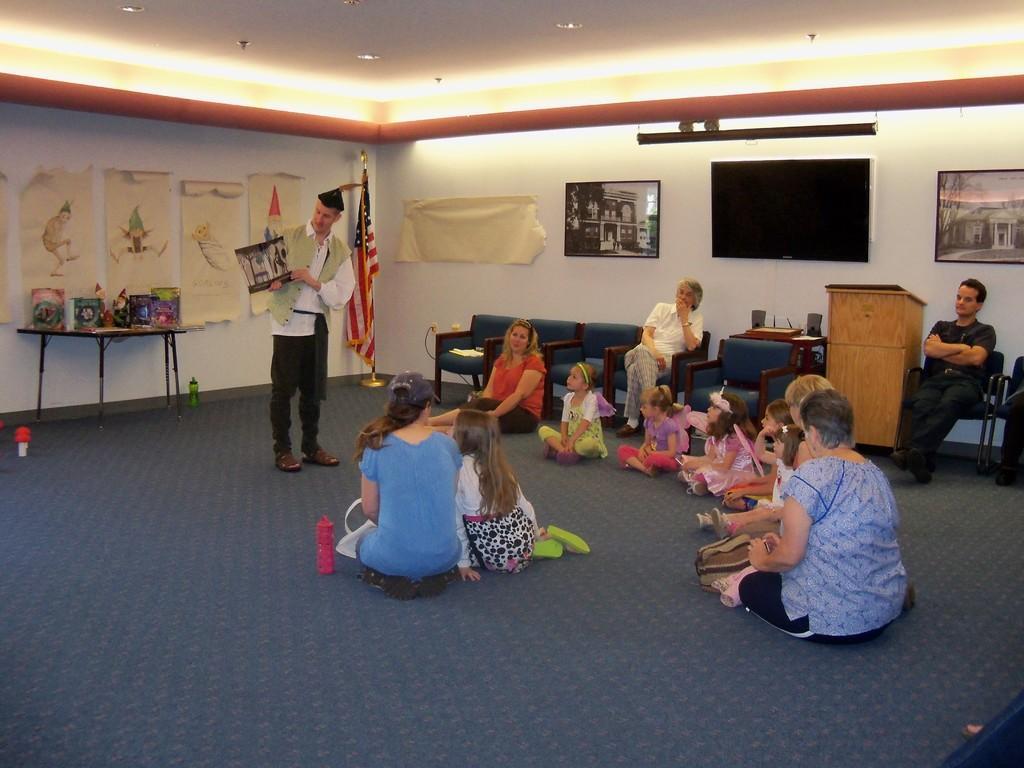Describe this image in one or two sentences. In the center of the image there are people sitting on the floor. In the background of the image there is wall. There are photo frames. There is a tv. There is a person standing and he is holding photo in his hand. At the top of the image there is a ceiling with lights. At the bottom of the image there is carpet. 